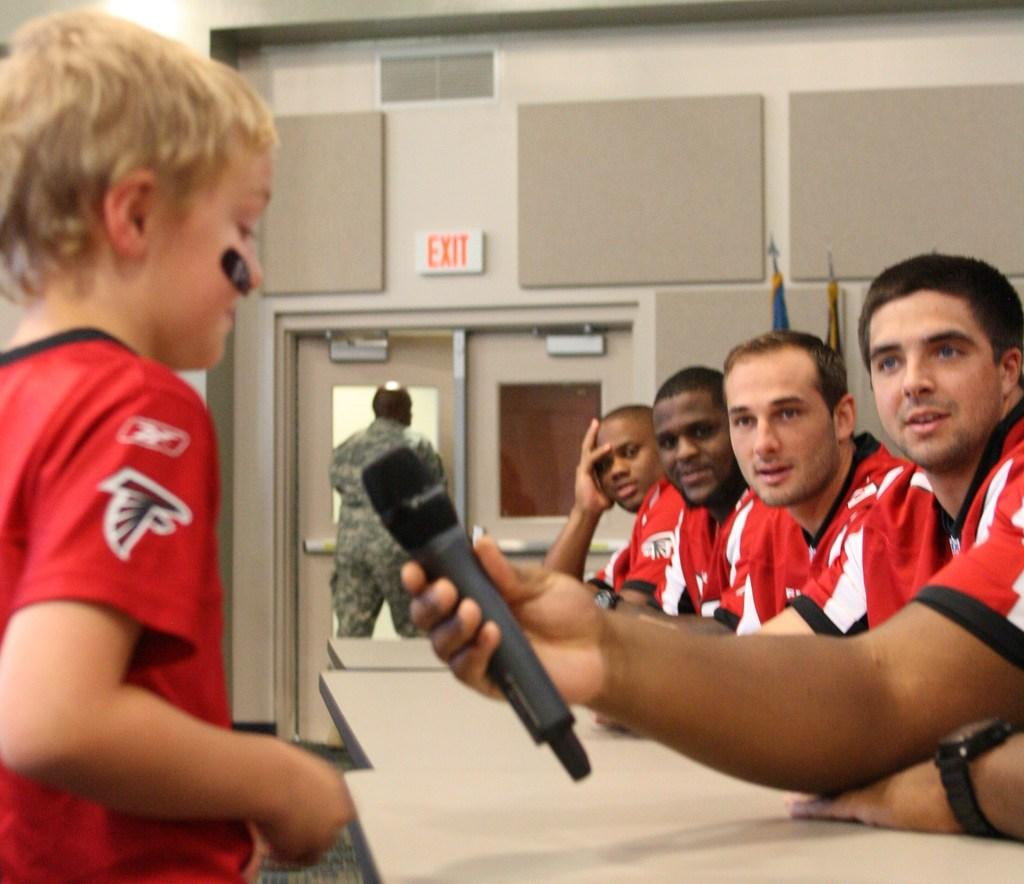<image>
Relay a brief, clear account of the picture shown. a prson in a Falcons shirt talking into a mic 